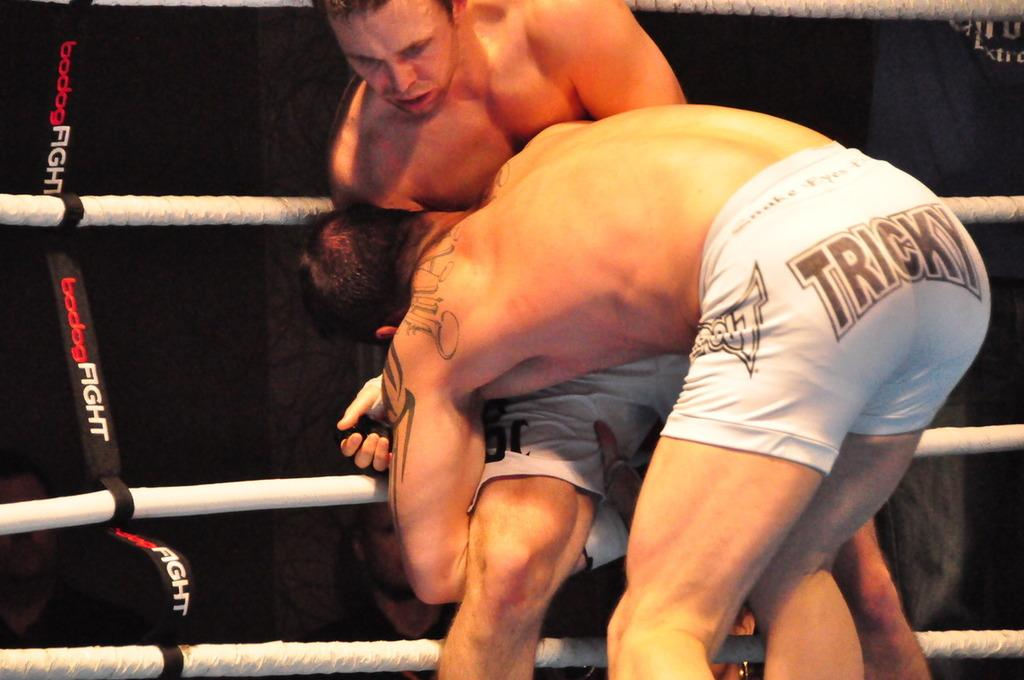<image>
Write a terse but informative summary of the picture. Two men try to grapple each other while wearing white shorts that say Tricky on them. 